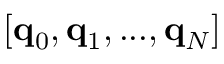Convert formula to latex. <formula><loc_0><loc_0><loc_500><loc_500>[ \mathbf q _ { 0 } , \mathbf q _ { 1 } , \dots , \mathbf q _ { N } ]</formula> 